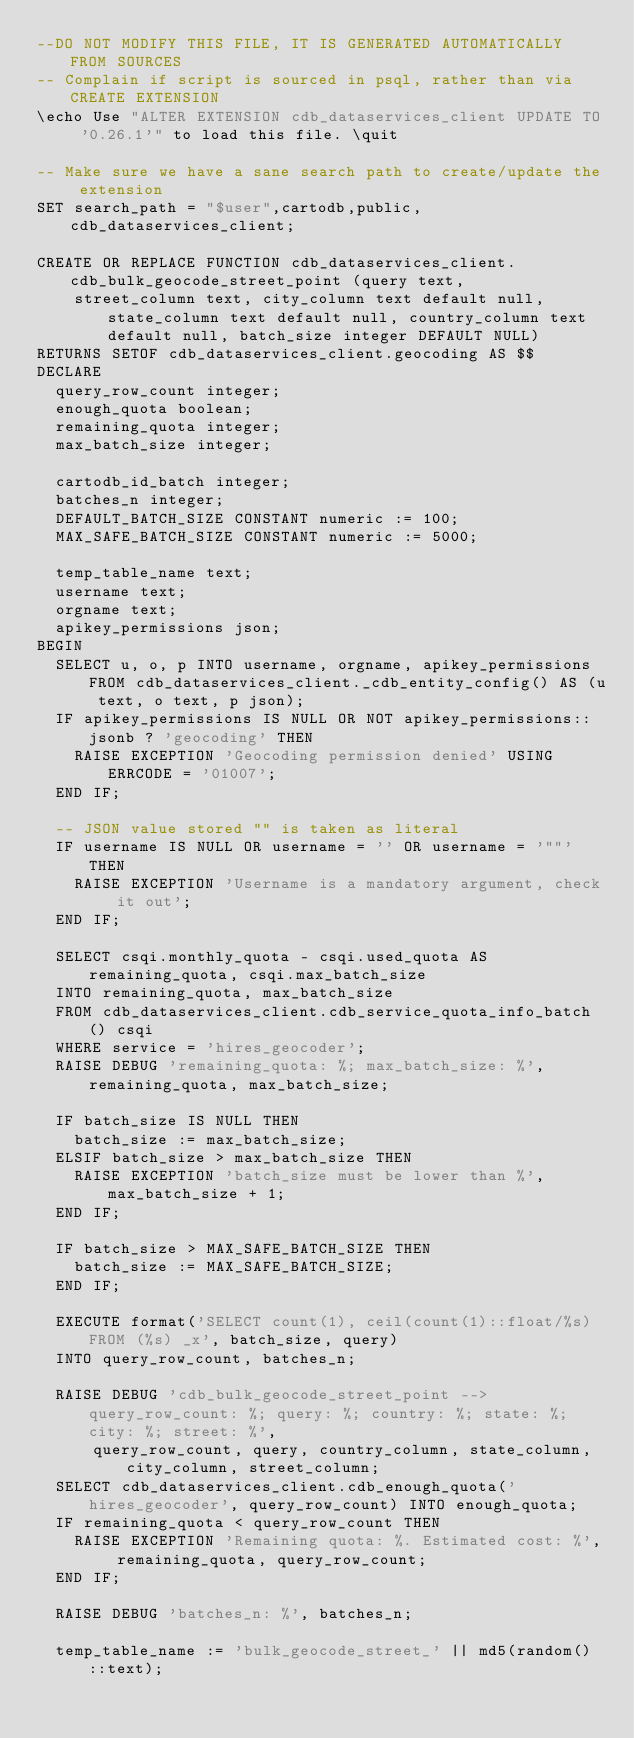<code> <loc_0><loc_0><loc_500><loc_500><_SQL_>--DO NOT MODIFY THIS FILE, IT IS GENERATED AUTOMATICALLY FROM SOURCES
-- Complain if script is sourced in psql, rather than via CREATE EXTENSION
\echo Use "ALTER EXTENSION cdb_dataservices_client UPDATE TO '0.26.1'" to load this file. \quit

-- Make sure we have a sane search path to create/update the extension
SET search_path = "$user",cartodb,public,cdb_dataservices_client;

CREATE OR REPLACE FUNCTION cdb_dataservices_client.cdb_bulk_geocode_street_point (query text,
    street_column text, city_column text default null, state_column text default null, country_column text default null, batch_size integer DEFAULT NULL)
RETURNS SETOF cdb_dataservices_client.geocoding AS $$
DECLARE
  query_row_count integer;
  enough_quota boolean;
  remaining_quota integer;
  max_batch_size integer;

  cartodb_id_batch integer;
  batches_n integer;
  DEFAULT_BATCH_SIZE CONSTANT numeric := 100;
  MAX_SAFE_BATCH_SIZE CONSTANT numeric := 5000;

  temp_table_name text;
  username text;
  orgname text;
  apikey_permissions json;
BEGIN
  SELECT u, o, p INTO username, orgname, apikey_permissions FROM cdb_dataservices_client._cdb_entity_config() AS (u text, o text, p json);
  IF apikey_permissions IS NULL OR NOT apikey_permissions::jsonb ? 'geocoding' THEN
    RAISE EXCEPTION 'Geocoding permission denied' USING ERRCODE = '01007';
  END IF;

  -- JSON value stored "" is taken as literal
  IF username IS NULL OR username = '' OR username = '""' THEN
    RAISE EXCEPTION 'Username is a mandatory argument, check it out';
  END IF;

  SELECT csqi.monthly_quota - csqi.used_quota AS remaining_quota, csqi.max_batch_size
  INTO remaining_quota, max_batch_size
  FROM cdb_dataservices_client.cdb_service_quota_info_batch() csqi
  WHERE service = 'hires_geocoder';
  RAISE DEBUG 'remaining_quota: %; max_batch_size: %', remaining_quota, max_batch_size;

  IF batch_size IS NULL THEN
    batch_size := max_batch_size;
  ELSIF batch_size > max_batch_size THEN
    RAISE EXCEPTION 'batch_size must be lower than %', max_batch_size + 1;
  END IF;

  IF batch_size > MAX_SAFE_BATCH_SIZE THEN
    batch_size := MAX_SAFE_BATCH_SIZE;
  END IF;

  EXECUTE format('SELECT count(1), ceil(count(1)::float/%s) FROM (%s) _x', batch_size, query)
  INTO query_row_count, batches_n;

  RAISE DEBUG 'cdb_bulk_geocode_street_point --> query_row_count: %; query: %; country: %; state: %; city: %; street: %',
      query_row_count, query, country_column, state_column, city_column, street_column;
  SELECT cdb_dataservices_client.cdb_enough_quota('hires_geocoder', query_row_count) INTO enough_quota;
  IF remaining_quota < query_row_count THEN
    RAISE EXCEPTION 'Remaining quota: %. Estimated cost: %', remaining_quota, query_row_count;
  END IF;

  RAISE DEBUG 'batches_n: %', batches_n;

  temp_table_name := 'bulk_geocode_street_' || md5(random()::text);
</code> 